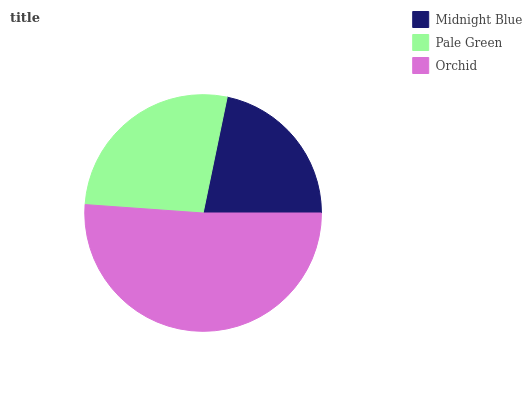Is Midnight Blue the minimum?
Answer yes or no. Yes. Is Orchid the maximum?
Answer yes or no. Yes. Is Pale Green the minimum?
Answer yes or no. No. Is Pale Green the maximum?
Answer yes or no. No. Is Pale Green greater than Midnight Blue?
Answer yes or no. Yes. Is Midnight Blue less than Pale Green?
Answer yes or no. Yes. Is Midnight Blue greater than Pale Green?
Answer yes or no. No. Is Pale Green less than Midnight Blue?
Answer yes or no. No. Is Pale Green the high median?
Answer yes or no. Yes. Is Pale Green the low median?
Answer yes or no. Yes. Is Midnight Blue the high median?
Answer yes or no. No. Is Orchid the low median?
Answer yes or no. No. 